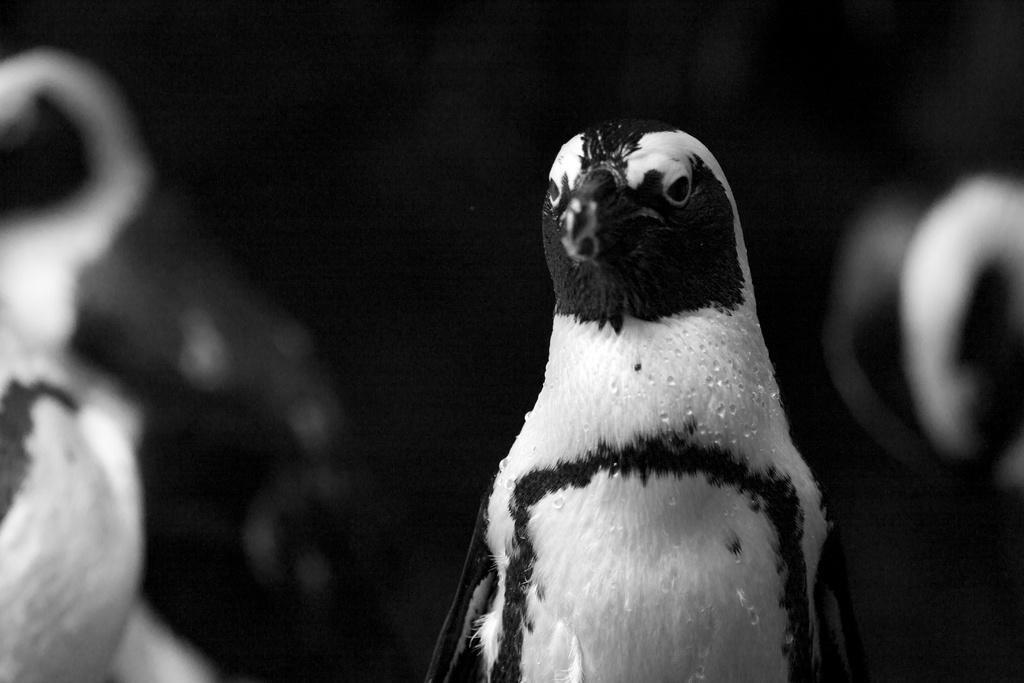How would you summarize this image in a sentence or two? In this image I can see the bird and the image is in black and white. 